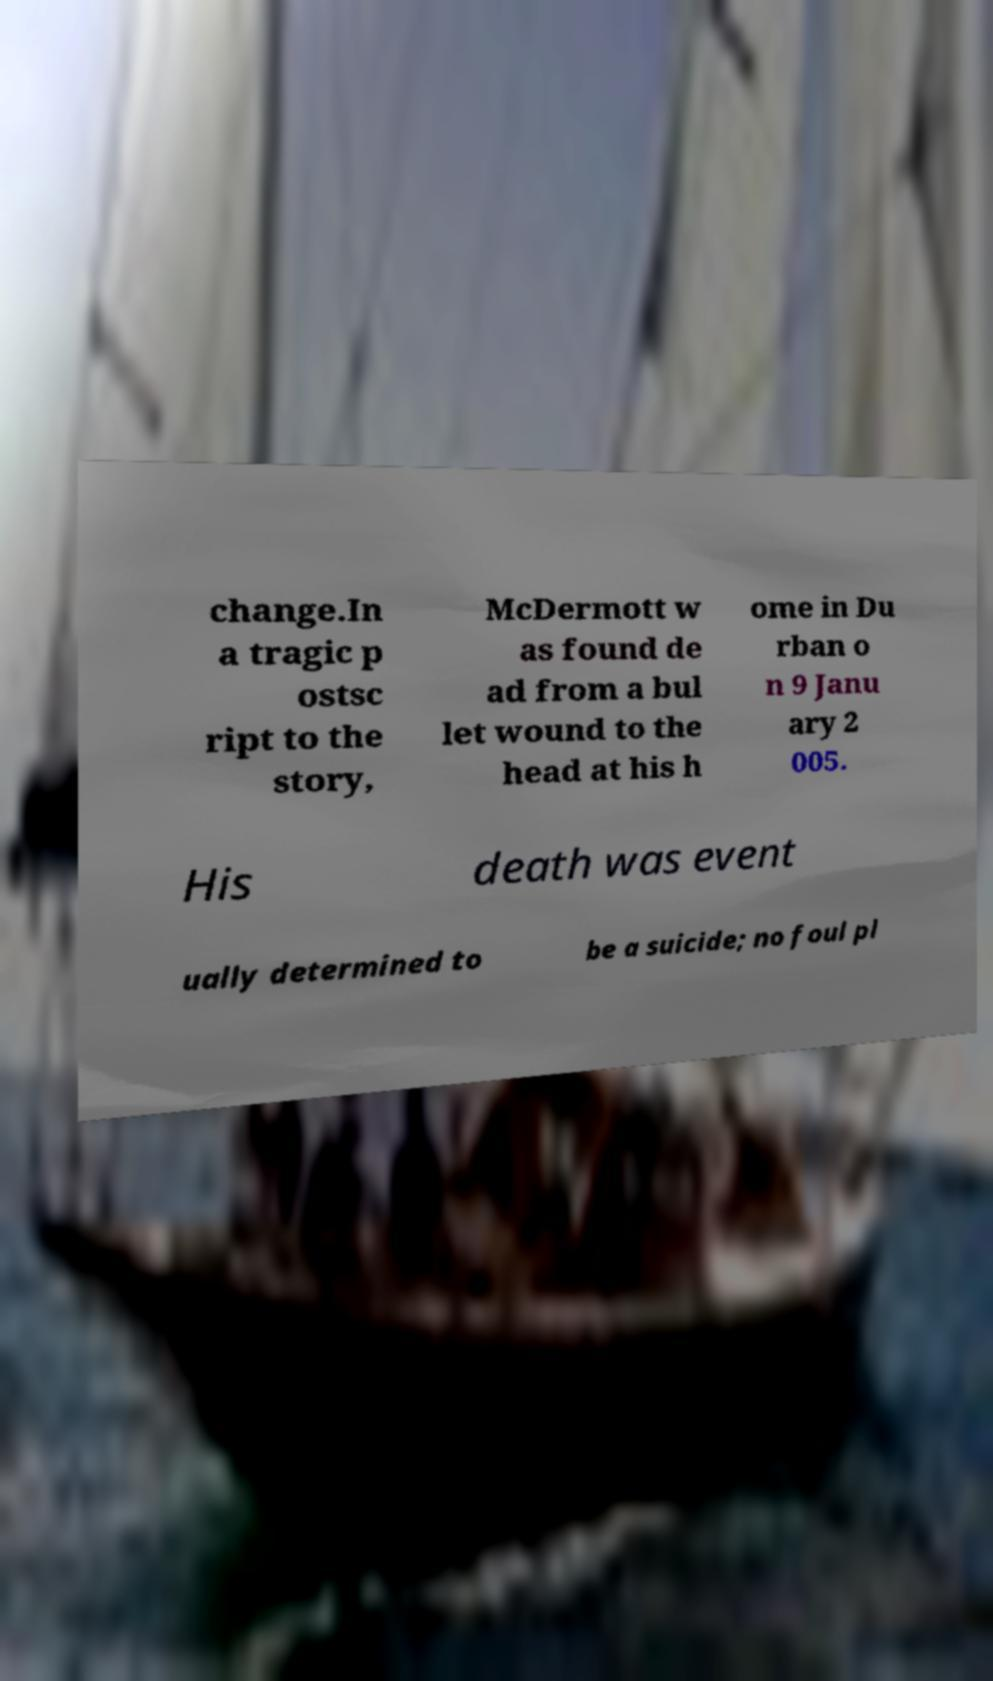I need the written content from this picture converted into text. Can you do that? change.In a tragic p ostsc ript to the story, McDermott w as found de ad from a bul let wound to the head at his h ome in Du rban o n 9 Janu ary 2 005. His death was event ually determined to be a suicide; no foul pl 